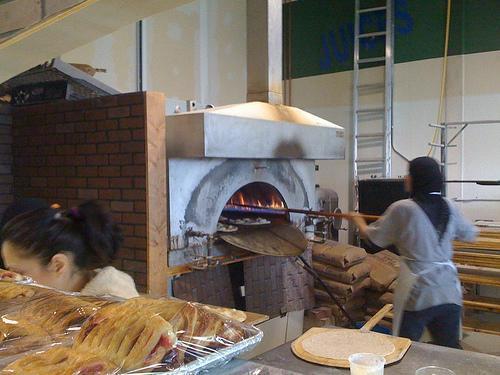How many workers are pictured?
Give a very brief answer. 2. How many ladders are shown?
Give a very brief answer. 1. How many people are there?
Give a very brief answer. 2. 